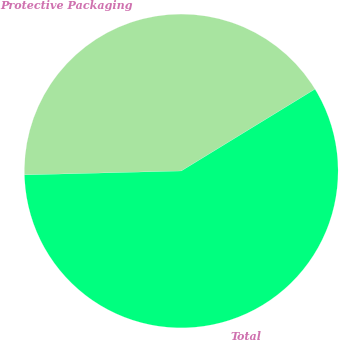Convert chart. <chart><loc_0><loc_0><loc_500><loc_500><pie_chart><fcel>Protective Packaging<fcel>Total<nl><fcel>41.66%<fcel>58.34%<nl></chart> 